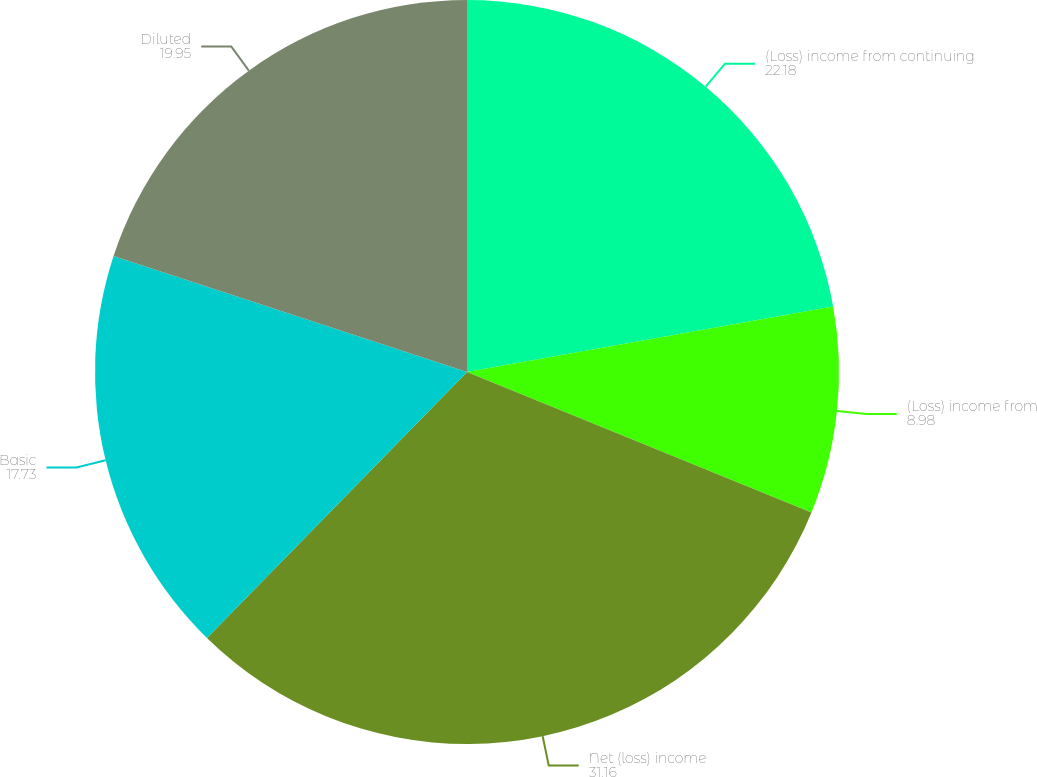<chart> <loc_0><loc_0><loc_500><loc_500><pie_chart><fcel>(Loss) income from continuing<fcel>(Loss) income from<fcel>Net (loss) income<fcel>Basic<fcel>Diluted<nl><fcel>22.18%<fcel>8.98%<fcel>31.16%<fcel>17.73%<fcel>19.95%<nl></chart> 